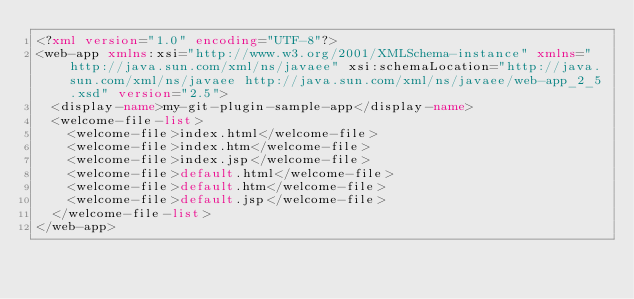Convert code to text. <code><loc_0><loc_0><loc_500><loc_500><_XML_><?xml version="1.0" encoding="UTF-8"?>
<web-app xmlns:xsi="http://www.w3.org/2001/XMLSchema-instance" xmlns="http://java.sun.com/xml/ns/javaee" xsi:schemaLocation="http://java.sun.com/xml/ns/javaee http://java.sun.com/xml/ns/javaee/web-app_2_5.xsd" version="2.5">
  <display-name>my-git-plugin-sample-app</display-name>
  <welcome-file-list>
    <welcome-file>index.html</welcome-file>
    <welcome-file>index.htm</welcome-file>
    <welcome-file>index.jsp</welcome-file>
    <welcome-file>default.html</welcome-file>
    <welcome-file>default.htm</welcome-file>
    <welcome-file>default.jsp</welcome-file>
  </welcome-file-list>
</web-app></code> 